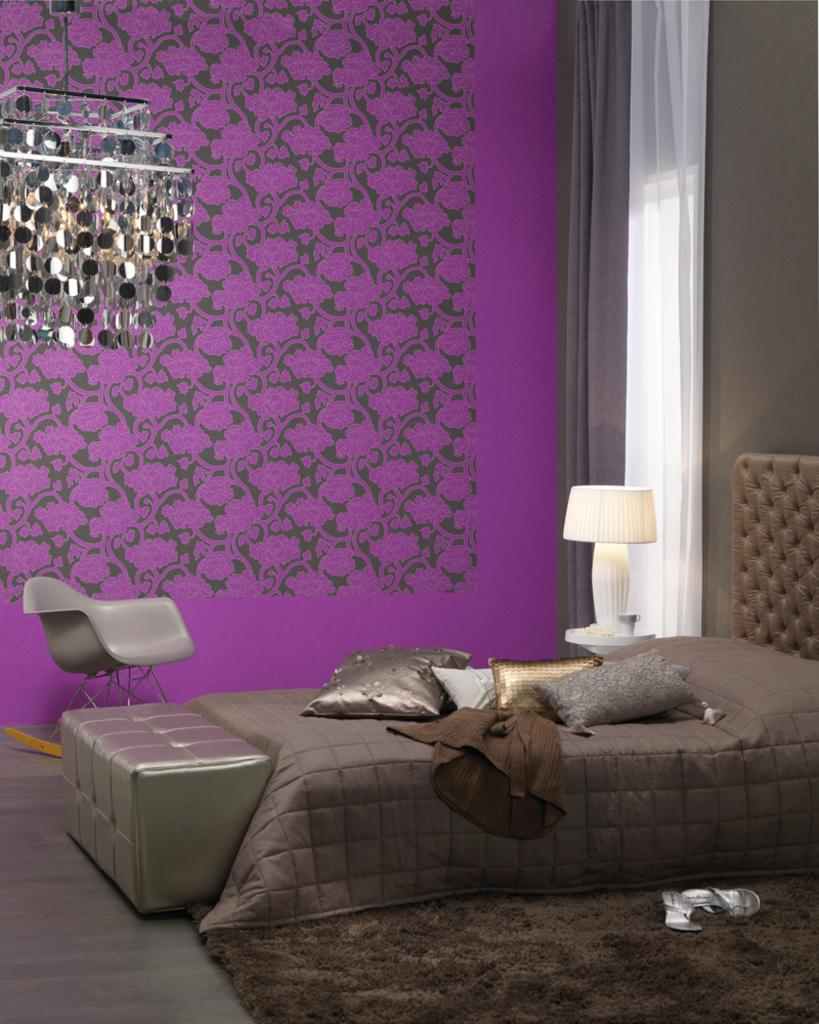What type of setting is shown in the image? The image depicts an inside view of a room. What can be seen on the bed in the image? There are pillows on the bed. What piece of furniture is visible in the background? There is a chair in the background. What can be used to provide illumination in the room? There are lights visible in the image. What type of education can be seen taking place in the image? There is no indication of education taking place in the image; it depicts a room with pillows on the bed, a chair in the background, and lights. 